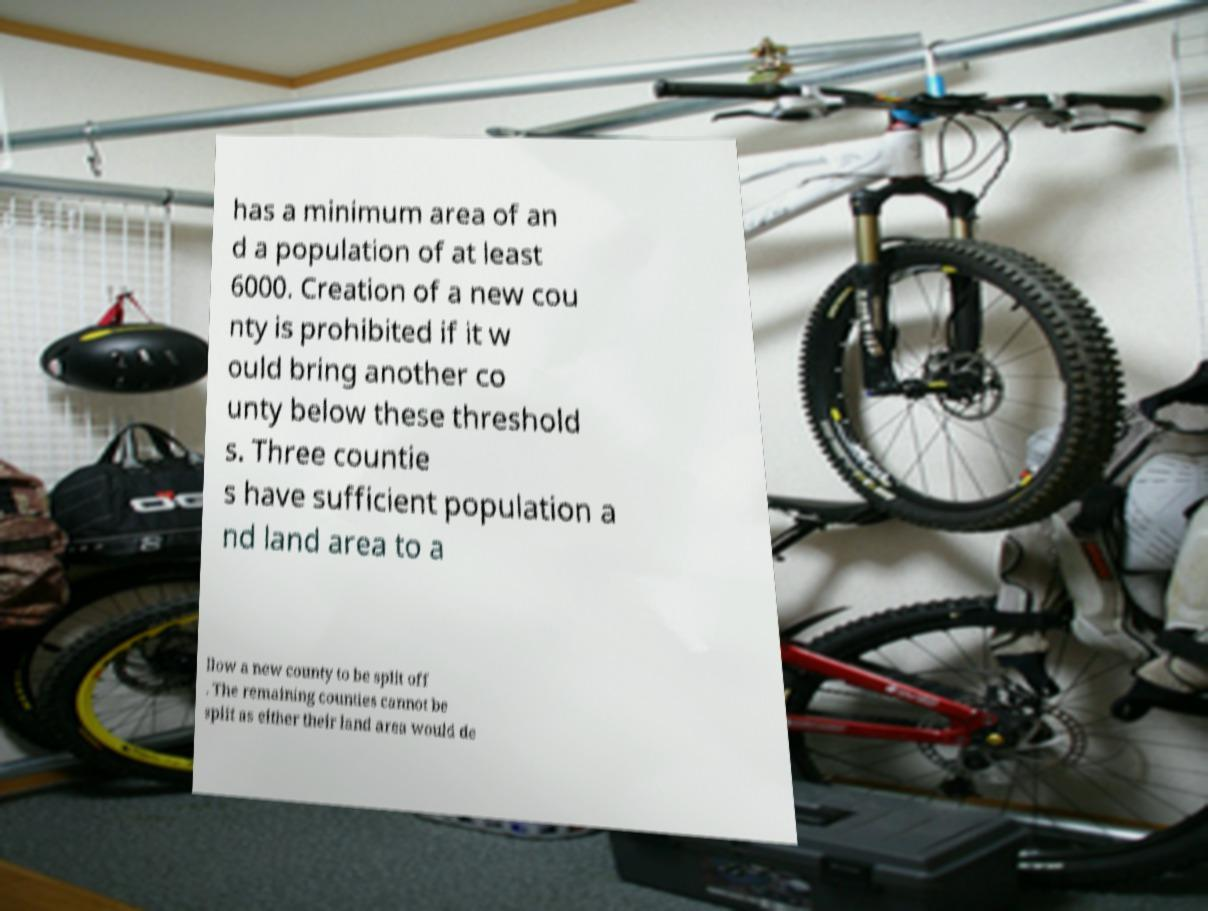Can you accurately transcribe the text from the provided image for me? has a minimum area of an d a population of at least 6000. Creation of a new cou nty is prohibited if it w ould bring another co unty below these threshold s. Three countie s have sufficient population a nd land area to a llow a new county to be split off . The remaining counties cannot be split as either their land area would de 